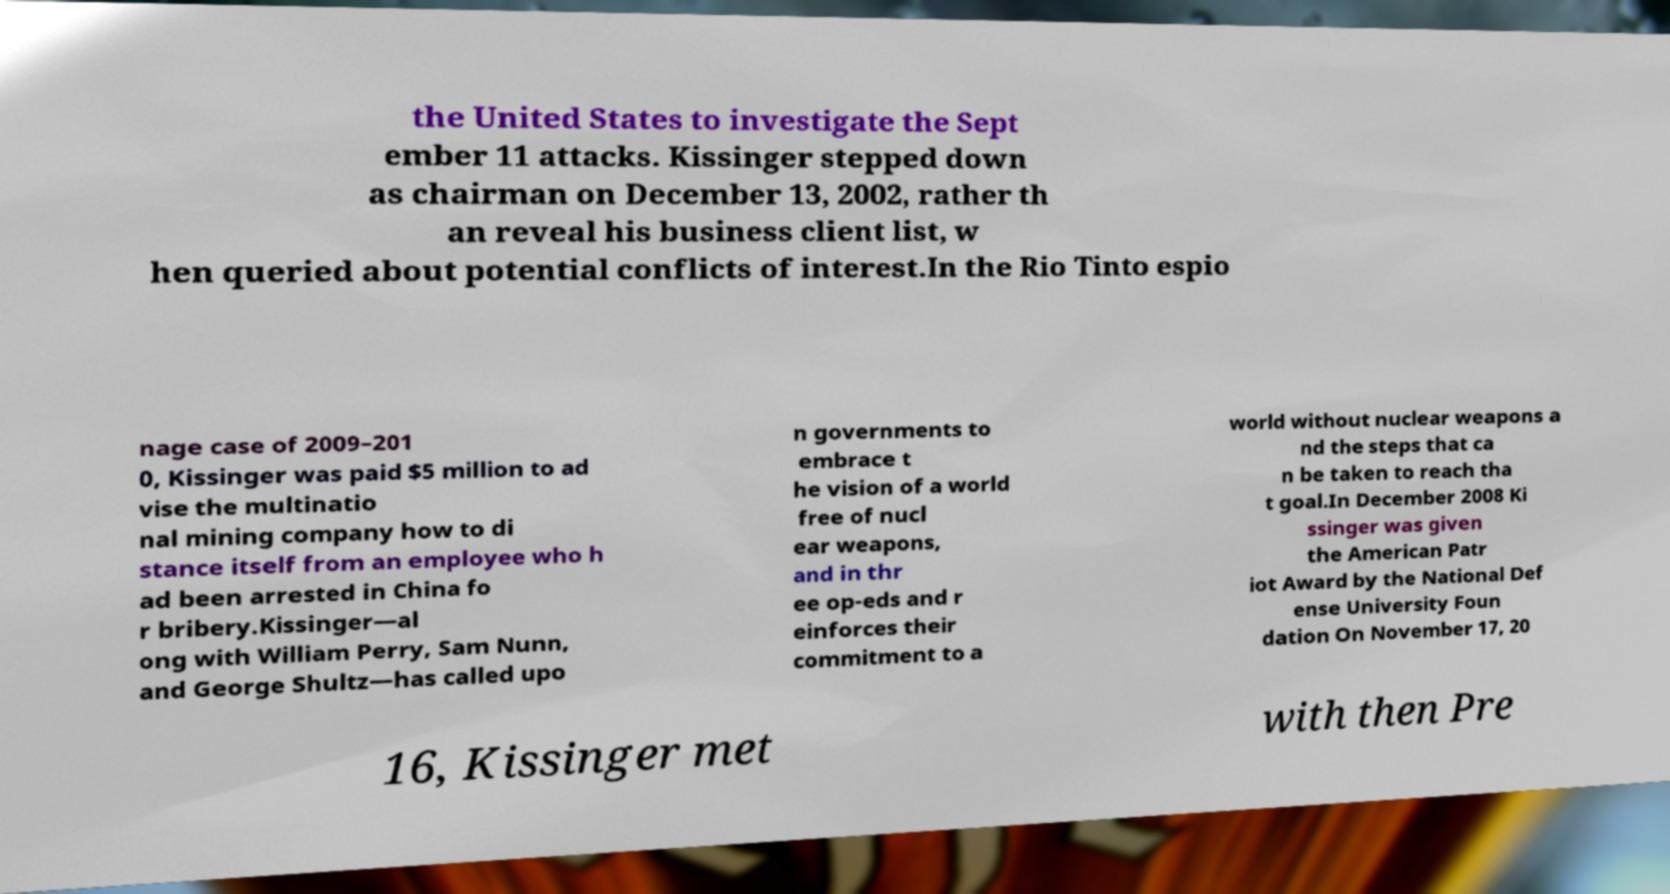Could you assist in decoding the text presented in this image and type it out clearly? the United States to investigate the Sept ember 11 attacks. Kissinger stepped down as chairman on December 13, 2002, rather th an reveal his business client list, w hen queried about potential conflicts of interest.In the Rio Tinto espio nage case of 2009–201 0, Kissinger was paid $5 million to ad vise the multinatio nal mining company how to di stance itself from an employee who h ad been arrested in China fo r bribery.Kissinger—al ong with William Perry, Sam Nunn, and George Shultz—has called upo n governments to embrace t he vision of a world free of nucl ear weapons, and in thr ee op-eds and r einforces their commitment to a world without nuclear weapons a nd the steps that ca n be taken to reach tha t goal.In December 2008 Ki ssinger was given the American Patr iot Award by the National Def ense University Foun dation On November 17, 20 16, Kissinger met with then Pre 